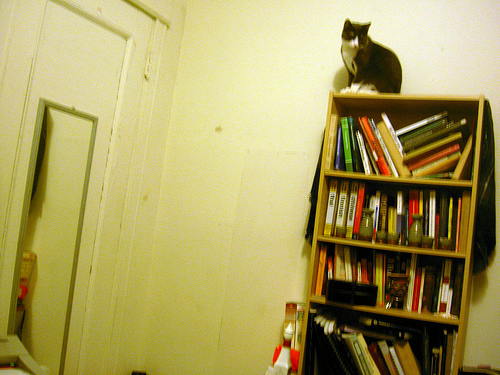<image>
Can you confirm if the mirror is in front of the cat? Yes. The mirror is positioned in front of the cat, appearing closer to the camera viewpoint. 